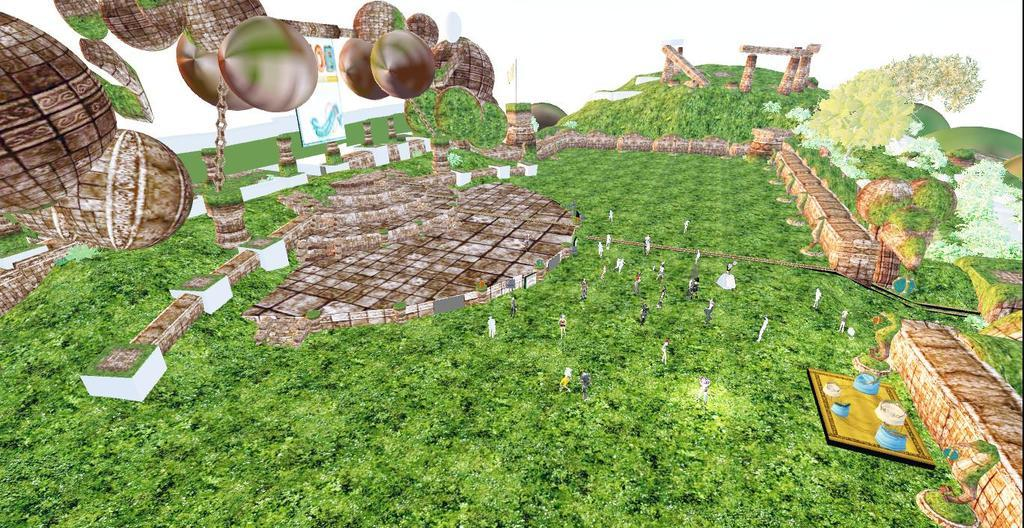What type of image is being described? The image is a graphical picture. What can be seen on the image? There is a poster, plants, animals, pillars, and other objects in the image. What is the color of the background in the image? The background of the image is white. How many boats are visible in the image? There are no boats present in the image. What unit of measurement is used to determine the size of the drawer in the image? There is no drawer present in the image. 